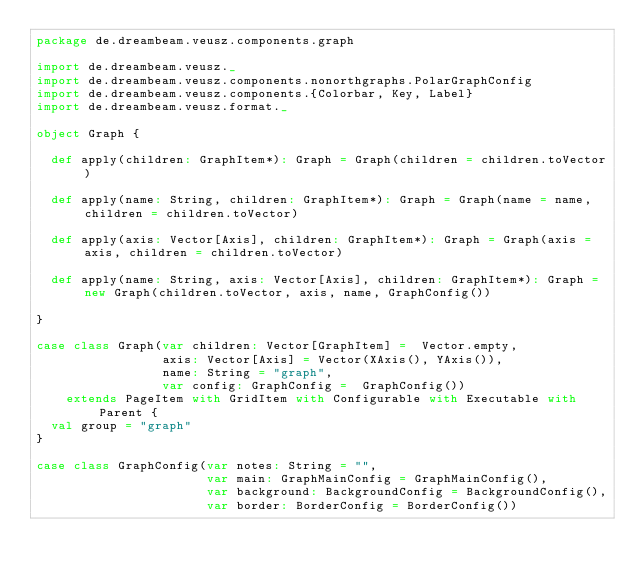<code> <loc_0><loc_0><loc_500><loc_500><_Scala_>package de.dreambeam.veusz.components.graph

import de.dreambeam.veusz._
import de.dreambeam.veusz.components.nonorthgraphs.PolarGraphConfig
import de.dreambeam.veusz.components.{Colorbar, Key, Label}
import de.dreambeam.veusz.format._

object Graph {

  def apply(children: GraphItem*): Graph = Graph(children = children.toVector)

  def apply(name: String, children: GraphItem*): Graph = Graph(name = name, children = children.toVector)

  def apply(axis: Vector[Axis], children: GraphItem*): Graph = Graph(axis = axis, children = children.toVector)

  def apply(name: String, axis: Vector[Axis], children: GraphItem*): Graph = new Graph(children.toVector, axis, name, GraphConfig())

}

case class Graph(var children: Vector[GraphItem] =  Vector.empty,
                 axis: Vector[Axis] = Vector(XAxis(), YAxis()),
                 name: String = "graph",
                 var config: GraphConfig =  GraphConfig())
    extends PageItem with GridItem with Configurable with Executable with Parent {
  val group = "graph"
}

case class GraphConfig(var notes: String = "",
                       var main: GraphMainConfig = GraphMainConfig(),
                       var background: BackgroundConfig = BackgroundConfig(),
                       var border: BorderConfig = BorderConfig())
</code> 